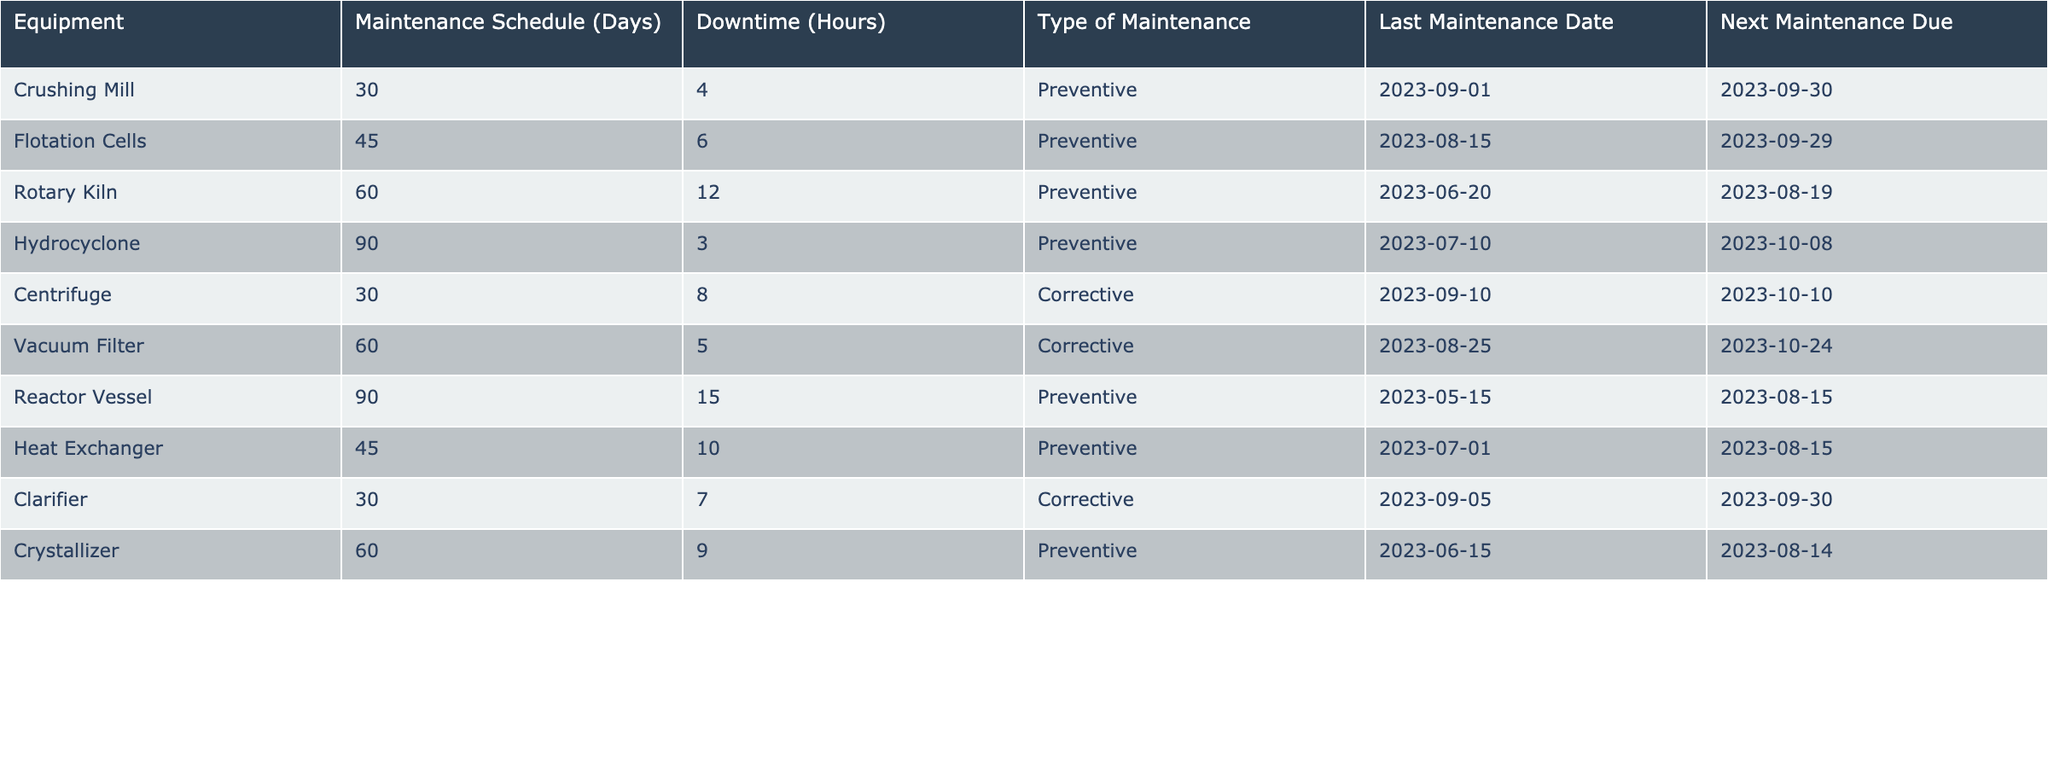What is the maintenance schedule for the Flotation Cells? The maintenance schedule for the Flotation Cells is stated in the table. Looking at the "Maintenance Schedule (Days)" column for Flotation Cells, it shows a value of 45 days.
Answer: 45 days How many hours of downtime does the Crushing Mill have? According to the table, the "Downtime (Hours)" for the Crushing Mill is 4 hours as specified in the respective row.
Answer: 4 hours Is the last maintenance date for the Reactor Vessel before today? The last maintenance date for the Reactor Vessel is 2023-05-15. To determine whether this date is before today, we compare it to the current date (let’s assume today is after 2023-10-01). Indeed, 2023-05-15 is before today, so the answer is yes.
Answer: Yes What type of maintenance is performed on the Centrifuge? By checking the "Type of Maintenance" column for the Centrifuge, we find that it is listed as "Corrective."
Answer: Corrective What is the total downtime for all Preventive maintenance types? We need to sum the downtime for each piece of equipment that has a "Preventive" maintenance type. From the table, the downtimes for Preventive equipment are: 6 (Flotation Cells) + 12 (Rotary Kiln) + 3 (Hydrocyclone) + 10 (Heat Exchanger) + 15 (Reactor Vessel) + 9 (Crystallizer) + 4 (Crushing Mill) = 59 hours.
Answer: 59 hours How many pieces of equipment have a maintenance schedule of 60 days or more? By examining the "Maintenance Schedule (Days)" column, we identify the pieces of equipment with 60 days or more: Rotary Kiln (60), Reactor Vessel (90), Vacuum Filter (60). This gives us a total of 3 pieces of equipment.
Answer: 3 Is there any equipment with corrective maintenance that has a downtime of more than 6 hours? In the table, we look at the "Corrective" maintenance types. The Centrifuge has a downtime of 8 hours, which is greater than 6 hours. Therefore, the answer is yes.
Answer: Yes What is the average downtime for all Preventive maintenance equipment? First, we will gather the downtimes for all Preventive maintenance types: Crushing Mill (4) + Flotation Cells (6) + Rotary Kiln (12) + Hydrocyclone (3) + Heat Exchanger (10) + Reactor Vessel (15) + Crystallizer (9). This results in a total of 59 hours. Since there are 7 Preventive maintenance types, the average is 59 / 7 = 8.43 hours.
Answer: 8.43 hours 